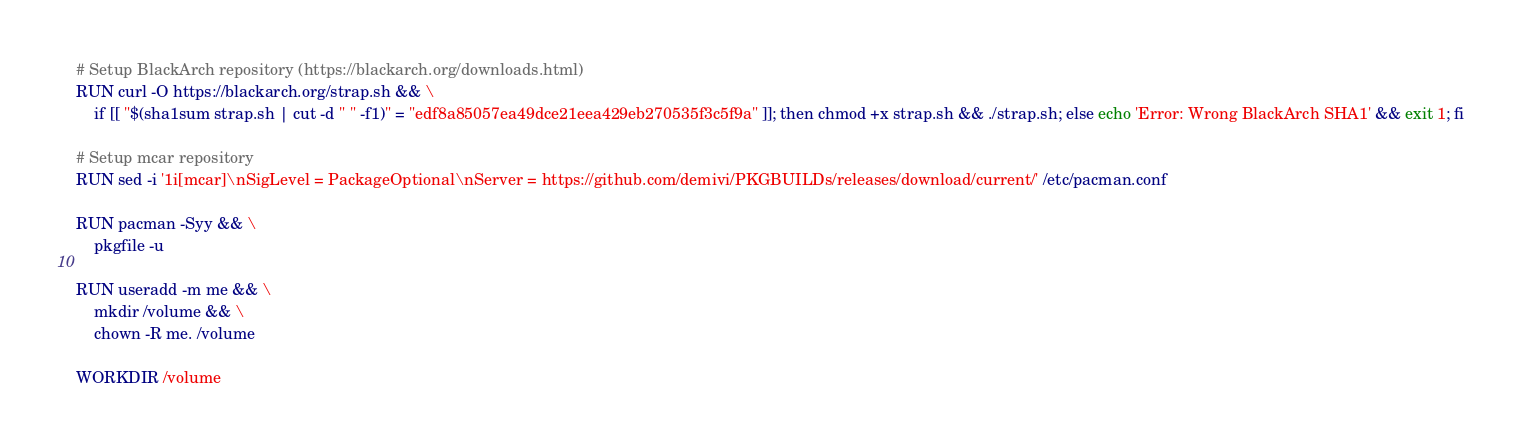<code> <loc_0><loc_0><loc_500><loc_500><_Dockerfile_>
# Setup BlackArch repository (https://blackarch.org/downloads.html)
RUN curl -O https://blackarch.org/strap.sh && \
    if [[ "$(sha1sum strap.sh | cut -d " " -f1)" = "edf8a85057ea49dce21eea429eb270535f3c5f9a" ]]; then chmod +x strap.sh && ./strap.sh; else echo 'Error: Wrong BlackArch SHA1' && exit 1; fi

# Setup mcar repository
RUN sed -i '1i[mcar]\nSigLevel = PackageOptional\nServer = https://github.com/demivi/PKGBUILDs/releases/download/current/' /etc/pacman.conf

RUN pacman -Syy && \
    pkgfile -u

RUN useradd -m me && \
    mkdir /volume && \
    chown -R me. /volume

WORKDIR /volume
</code> 